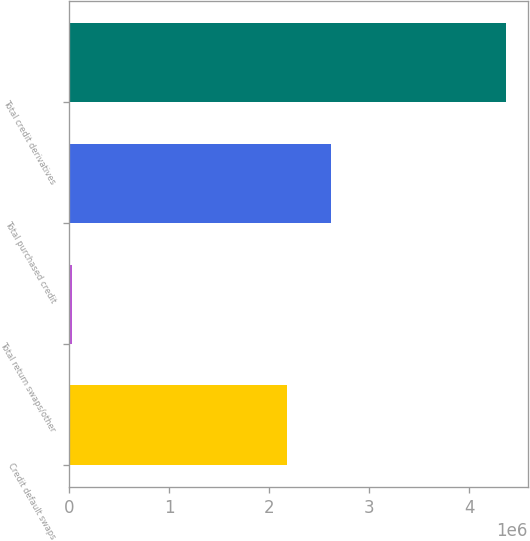<chart> <loc_0><loc_0><loc_500><loc_500><bar_chart><fcel>Credit default swaps<fcel>Total return swaps/other<fcel>Total purchased credit<fcel>Total credit derivatives<nl><fcel>2.1847e+06<fcel>26038<fcel>2.61877e+06<fcel>4.3667e+06<nl></chart> 